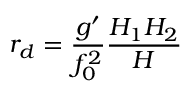<formula> <loc_0><loc_0><loc_500><loc_500>r _ { d } = \frac { g ^ { \prime } } { f _ { 0 } ^ { 2 } } \frac { H _ { 1 } H _ { 2 } } { H }</formula> 